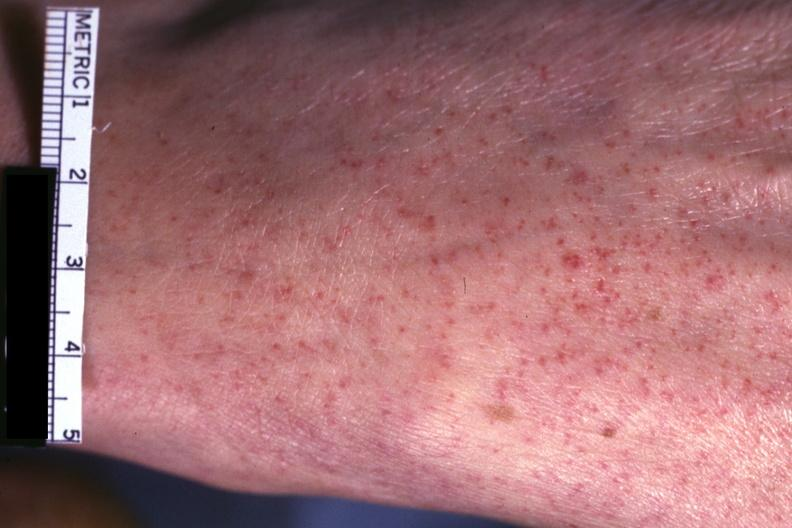s petechiae present?
Answer the question using a single word or phrase. Yes 